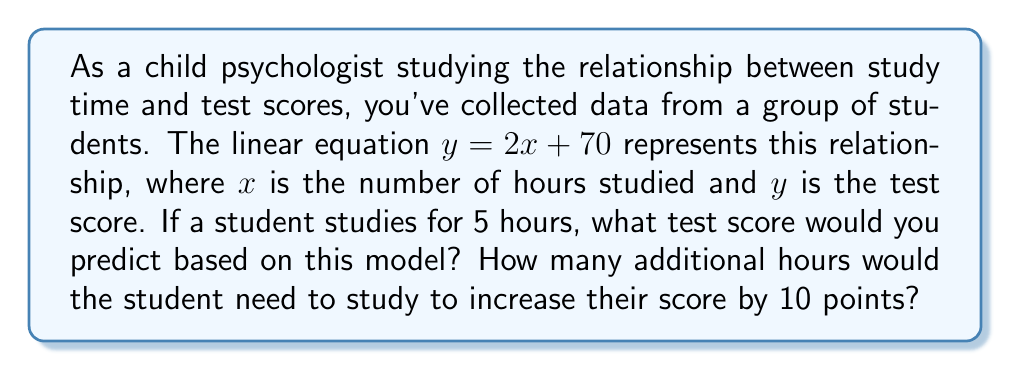What is the answer to this math problem? 1. To find the predicted test score for 5 hours of study:
   Substitute $x = 5$ into the equation $y = 2x + 70$
   $y = 2(5) + 70$
   $y = 10 + 70 = 80$

2. To find how many additional hours are needed to increase the score by 10 points:
   Let $\Delta y = 10$ (the change in score)
   From the equation, we see that for every 1 hour increase in study time, the score increases by 2 points.
   So, $\Delta x = \frac{\Delta y}{2} = \frac{10}{2} = 5$

Therefore, the student would need to study for an additional 5 hours to increase their score by 10 points.
Answer: 80; 5 hours 